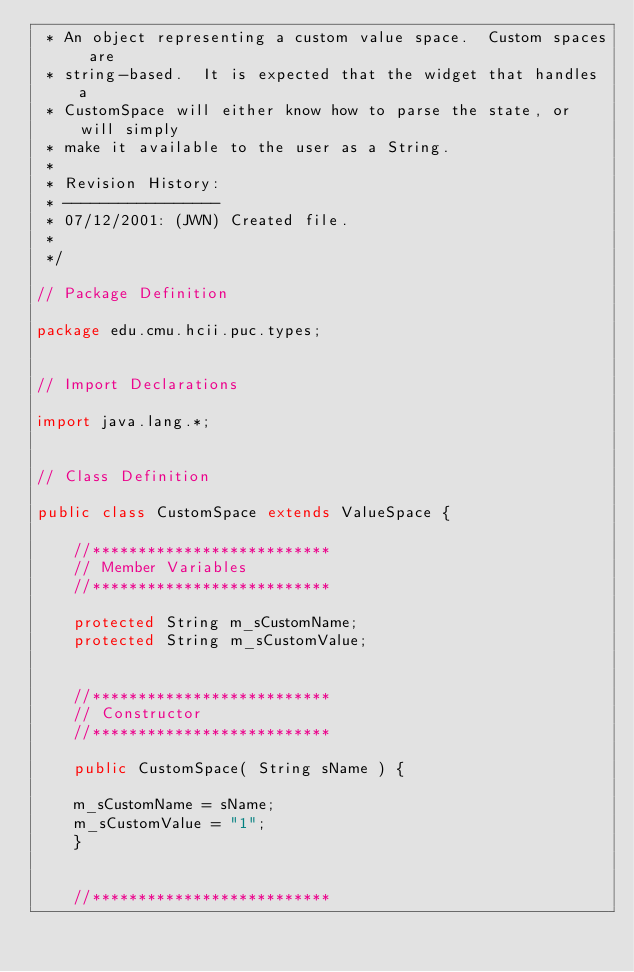Convert code to text. <code><loc_0><loc_0><loc_500><loc_500><_Java_> * An object representing a custom value space.  Custom spaces are
 * string-based.  It is expected that the widget that handles a
 * CustomSpace will either know how to parse the state, or will simply
 * make it available to the user as a String.
 *
 * Revision History:
 * -----------------
 * 07/12/2001: (JWN) Created file.
 *
 */

// Package Definition

package edu.cmu.hcii.puc.types;


// Import Declarations

import java.lang.*;


// Class Definition

public class CustomSpace extends ValueSpace {

    //**************************
    // Member Variables
    //**************************

    protected String m_sCustomName;
    protected String m_sCustomValue;


    //**************************
    // Constructor
    //**************************

    public CustomSpace( String sName ) { 

	m_sCustomName = sName;
	m_sCustomValue = "1";
    }


    //**************************</code> 